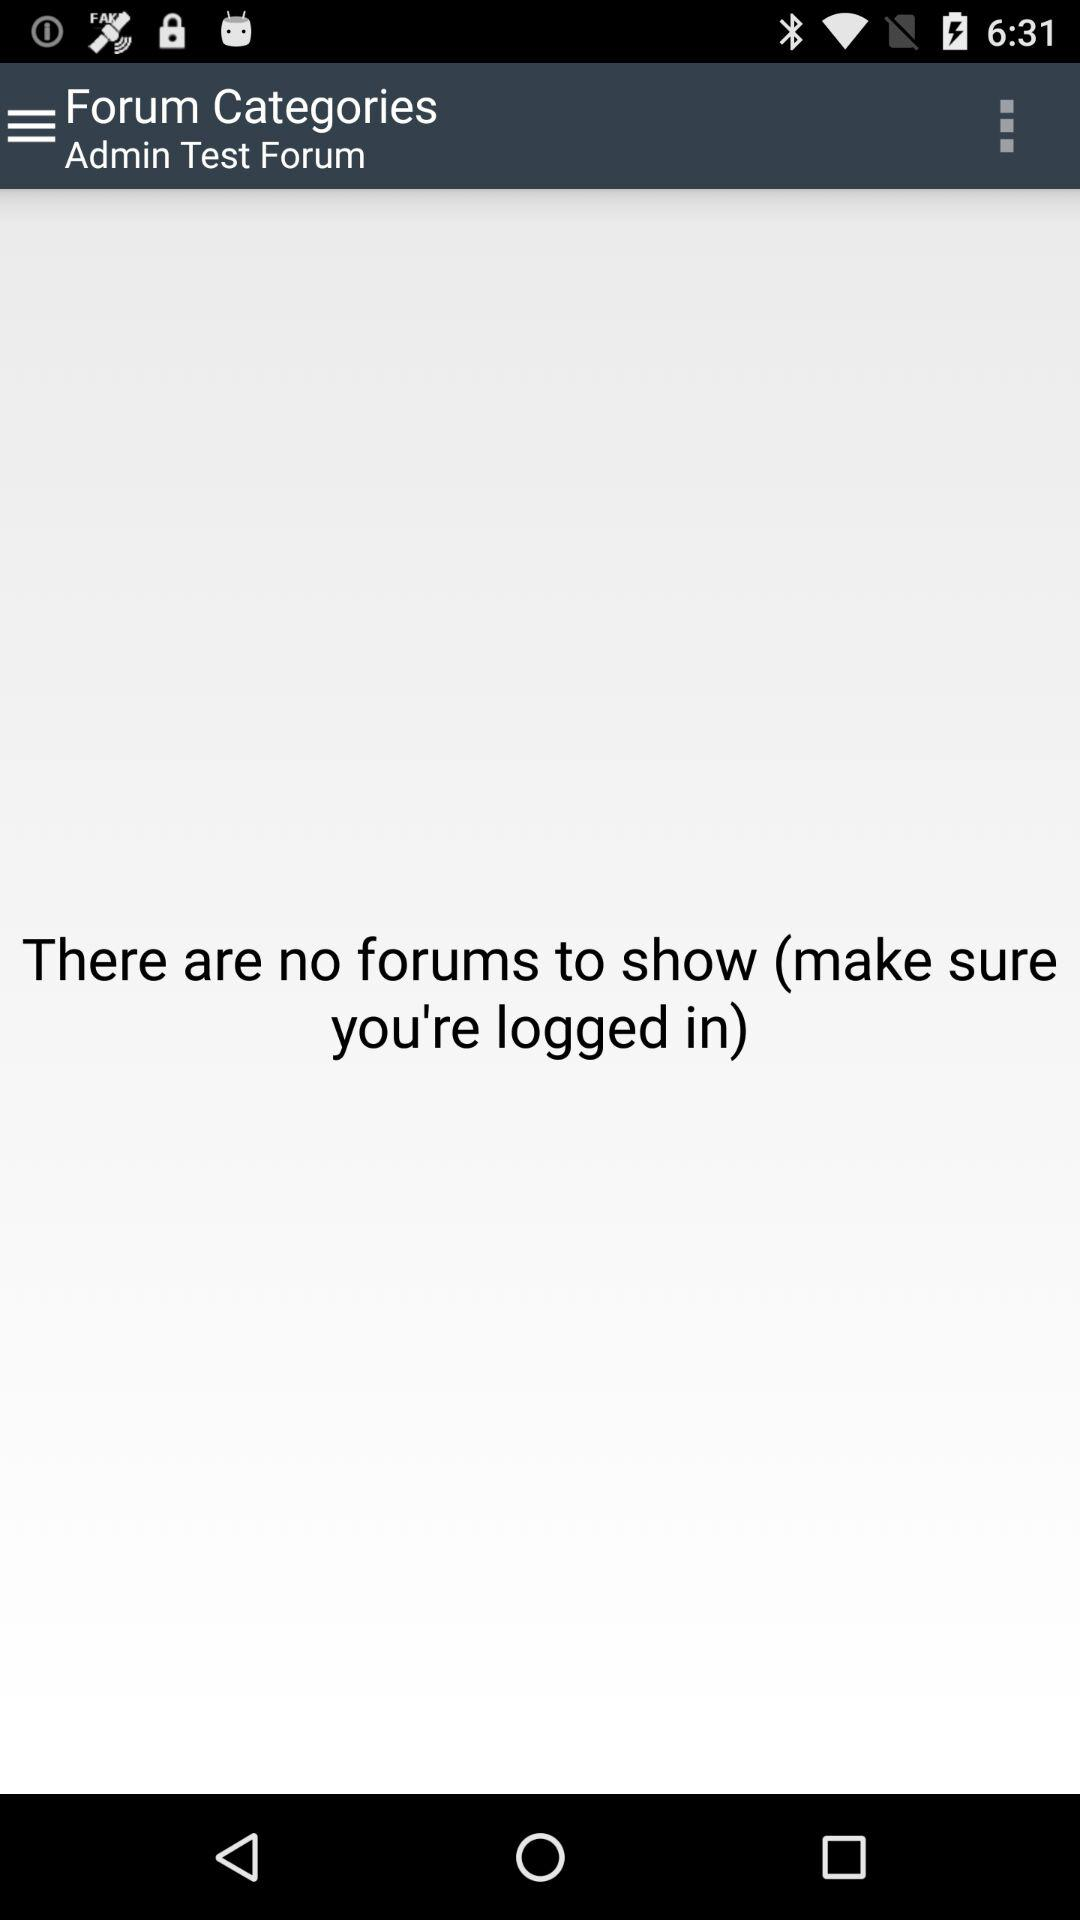How many forums are there? There are no forums. 